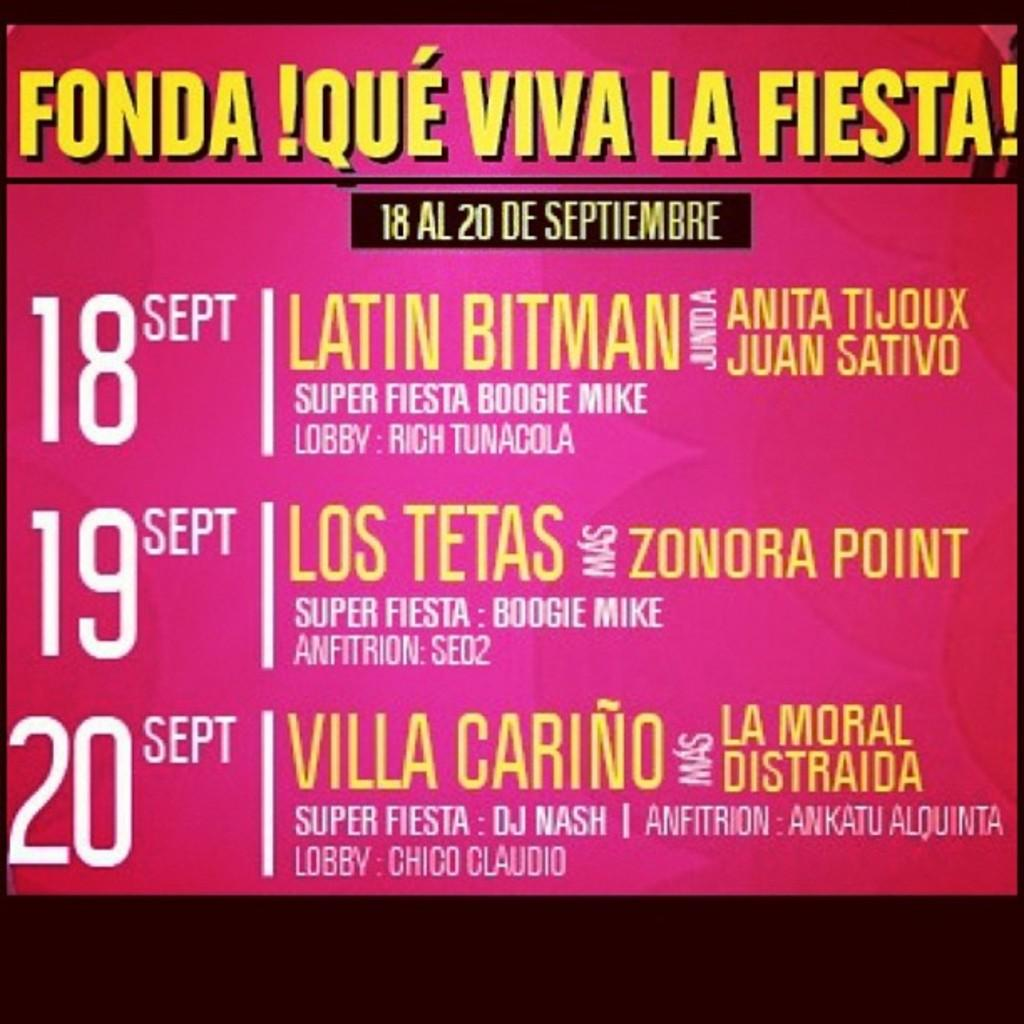<image>
Share a concise interpretation of the image provided. A poster advertises Fonda Que Viva La Fiesta, September 18 - 20. 